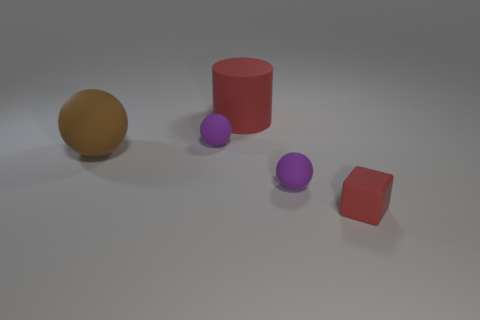Subtract all purple spheres. How many spheres are left? 1 Subtract all balls. How many objects are left? 2 Add 5 small red rubber things. How many objects exist? 10 Add 1 purple balls. How many purple balls are left? 3 Add 3 purple objects. How many purple objects exist? 5 Subtract all purple spheres. How many spheres are left? 1 Subtract 0 yellow balls. How many objects are left? 5 Subtract 1 cylinders. How many cylinders are left? 0 Subtract all blue cylinders. Subtract all gray spheres. How many cylinders are left? 1 Subtract all gray cylinders. How many cyan spheres are left? 0 